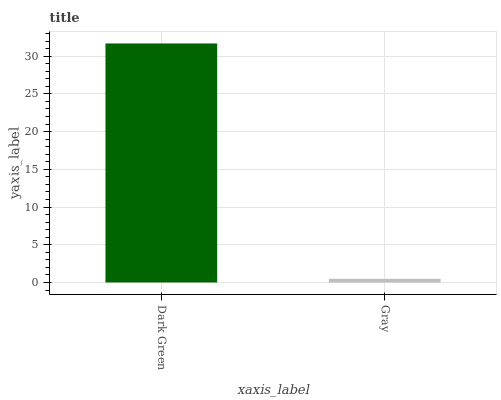Is Gray the maximum?
Answer yes or no. No. Is Dark Green greater than Gray?
Answer yes or no. Yes. Is Gray less than Dark Green?
Answer yes or no. Yes. Is Gray greater than Dark Green?
Answer yes or no. No. Is Dark Green less than Gray?
Answer yes or no. No. Is Dark Green the high median?
Answer yes or no. Yes. Is Gray the low median?
Answer yes or no. Yes. Is Gray the high median?
Answer yes or no. No. Is Dark Green the low median?
Answer yes or no. No. 